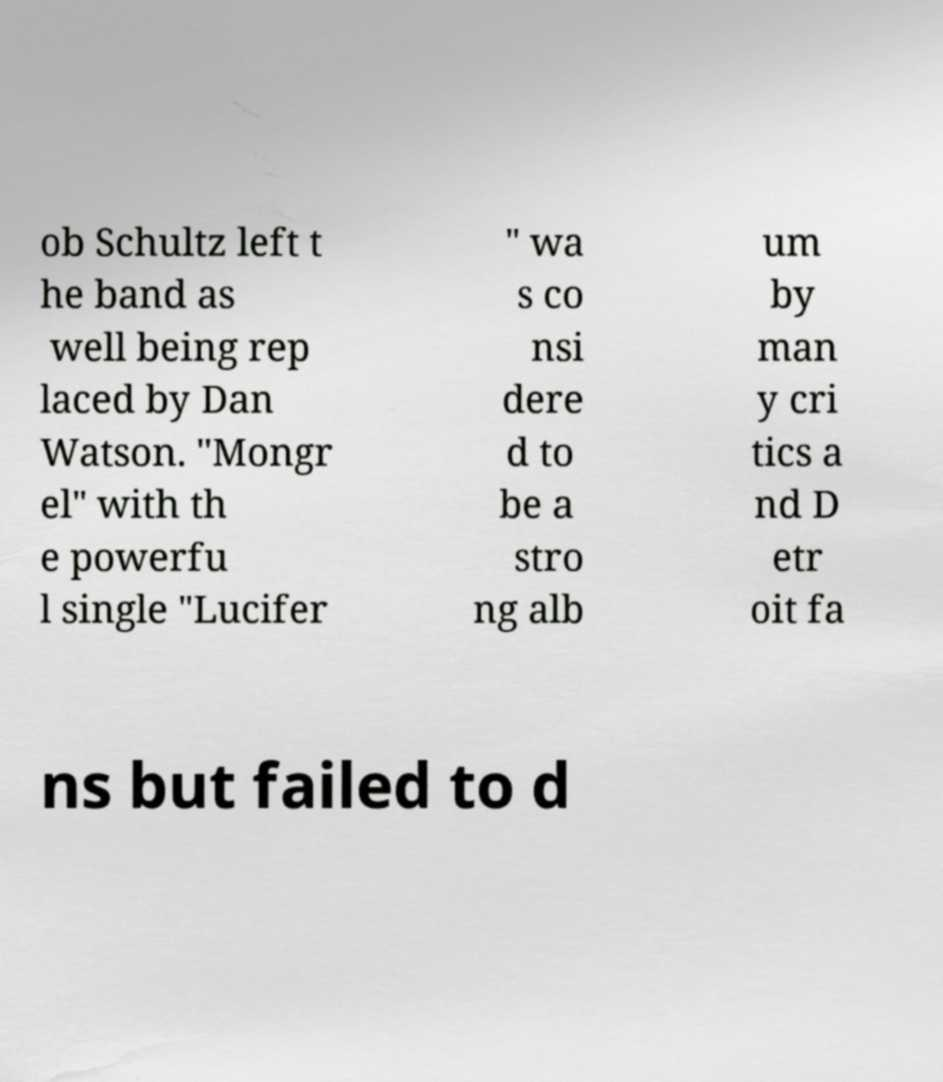I need the written content from this picture converted into text. Can you do that? ob Schultz left t he band as well being rep laced by Dan Watson. "Mongr el" with th e powerfu l single "Lucifer " wa s co nsi dere d to be a stro ng alb um by man y cri tics a nd D etr oit fa ns but failed to d 